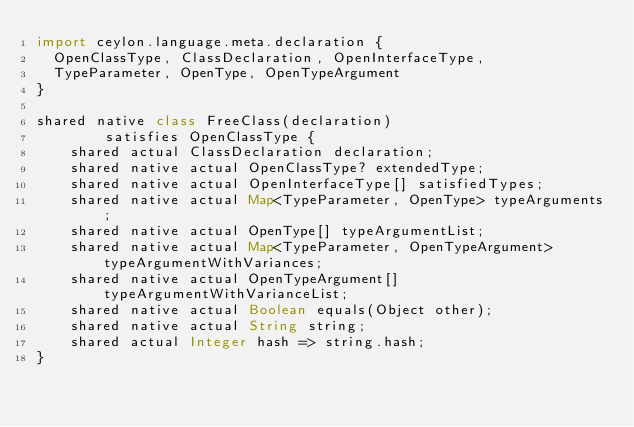<code> <loc_0><loc_0><loc_500><loc_500><_Ceylon_>import ceylon.language.meta.declaration {
  OpenClassType, ClassDeclaration, OpenInterfaceType,
  TypeParameter, OpenType, OpenTypeArgument
}

shared native class FreeClass(declaration)
        satisfies OpenClassType {
    shared actual ClassDeclaration declaration;
    shared native actual OpenClassType? extendedType;
    shared native actual OpenInterfaceType[] satisfiedTypes;
    shared native actual Map<TypeParameter, OpenType> typeArguments;
    shared native actual OpenType[] typeArgumentList;
    shared native actual Map<TypeParameter, OpenTypeArgument> typeArgumentWithVariances;
    shared native actual OpenTypeArgument[] typeArgumentWithVarianceList;
    shared native actual Boolean equals(Object other);
    shared native actual String string;
    shared actual Integer hash => string.hash;
}
</code> 